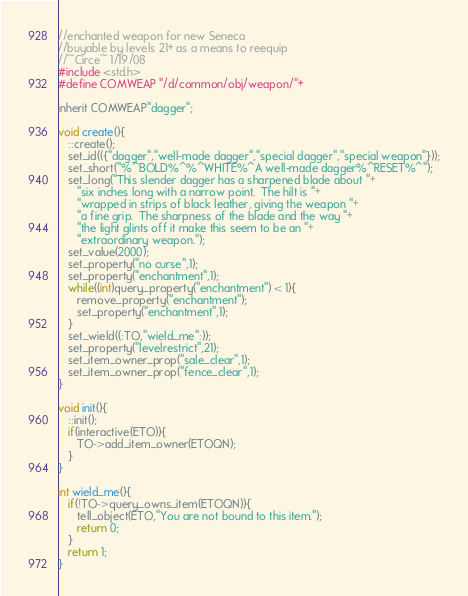Convert code to text. <code><loc_0><loc_0><loc_500><loc_500><_C_>//enchanted weapon for new Seneca
//buyable by levels 21+ as a means to reequip
//~Circe~ 1/19/08
#include <std.h>
#define COMWEAP "/d/common/obj/weapon/"+

inherit COMWEAP"dagger";

void create(){
   ::create();
   set_id(({"dagger","well-made dagger","special dagger","special weapon"}));
   set_short("%^BOLD%^%^WHITE%^A well-made dagger%^RESET%^");
   set_long("This slender dagger has a sharpened blade about "+
      "six inches long with a narrow point.  The hilt is "+
      "wrapped in strips of black leather, giving the weapon "+
      "a fine grip.  The sharpness of the blade and the way "+
      "the light glints off it make this seem to be an "+
      "extraordinary weapon.");
   set_value(2000);
   set_property("no curse",1);
   set_property("enchantment",1);
   while((int)query_property("enchantment") < 1){
      remove_property("enchantment");
      set_property("enchantment",1);
   }
   set_wield((:TO,"wield_me":));
   set_property("levelrestrict",21);
   set_item_owner_prop("sale_clear",1);
   set_item_owner_prop("fence_clear",1);
}

void init(){
   ::init();
   if(interactive(ETO)){
      TO->add_item_owner(ETOQN);
   }
}

int wield_me(){
   if(!TO->query_owns_item(ETOQN)){
      tell_object(ETO,"You are not bound to this item.");
      return 0;
   }
   return 1;
}
</code> 